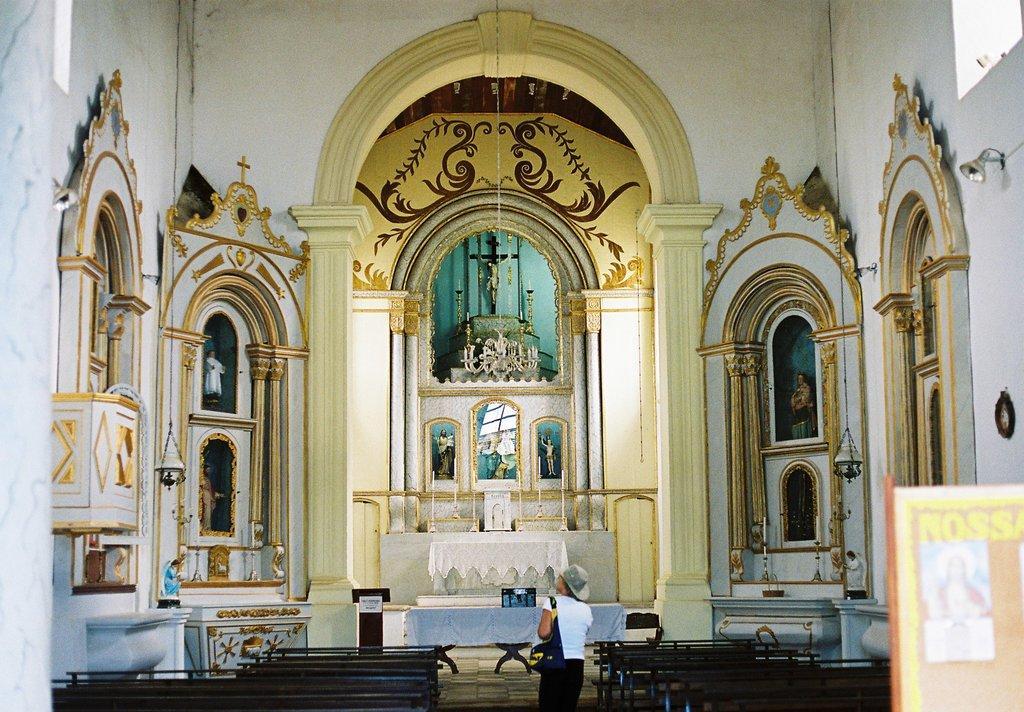In one or two sentences, can you explain what this image depicts? In this image there is a person carrying a bag is standing on the floor. He is wearing a cap. Before him there is a table covered with a cloth. An object is on the table. Beside the table there is a podium. On both sides of the person there are few benches on the floor. Few idols are kept inside the shelf. Few lamps are hanged from the roof. Few candle stands are kept on the shelf. Right bottom there is a banner. A lamp is attached to the wall. 